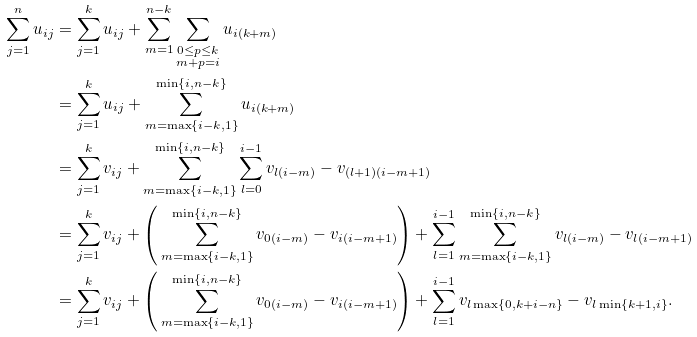<formula> <loc_0><loc_0><loc_500><loc_500>\sum _ { j = 1 } ^ { n } u _ { i j } & = \sum _ { j = 1 } ^ { k } u _ { i j } + \sum _ { m = 1 } ^ { n - k } \sum _ { \substack { 0 \leq p \leq k \\ m + p = i } } u _ { i ( k + m ) } \\ & = \sum _ { j = 1 } ^ { k } u _ { i j } + \sum _ { m = \max \{ i - k , 1 \} } ^ { \min \{ i , n - k \} } u _ { i ( k + m ) } \\ & = \sum _ { j = 1 } ^ { k } v _ { i j } + \sum _ { m = \max \{ i - k , 1 \} } ^ { \min \{ i , n - k \} } \sum _ { l = 0 } ^ { i - 1 } v _ { l ( i - m ) } - v _ { ( l + 1 ) ( i - m + 1 ) } \\ & = \sum _ { j = 1 } ^ { k } v _ { i j } + \left ( \, \sum _ { m = \max \{ i - k , 1 \} } ^ { \min \{ i , n - k \} } v _ { 0 ( i - m ) } - v _ { i ( i - m + 1 ) } \right ) + \sum _ { l = 1 } ^ { i - 1 } \sum _ { m = \max \{ i - k , 1 \} } ^ { \min \{ i , n - k \} } v _ { l ( i - m ) } - v _ { l ( i - m + 1 ) } \\ & = \sum _ { j = 1 } ^ { k } v _ { i j } + \left ( \, \sum _ { m = \max \{ i - k , 1 \} } ^ { \min \{ i , n - k \} } v _ { 0 ( i - m ) } - v _ { i ( i - m + 1 ) } \right ) + \sum _ { l = 1 } ^ { i - 1 } v _ { l \max \{ 0 , k + i - n \} } - v _ { l \min \{ k + 1 , i \} } .</formula> 